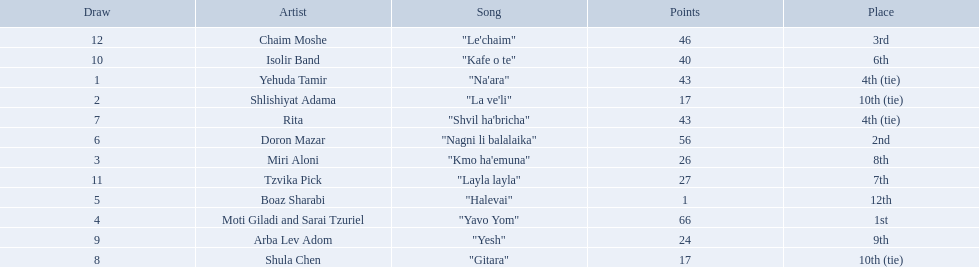How many artists are there? Yehuda Tamir, Shlishiyat Adama, Miri Aloni, Moti Giladi and Sarai Tzuriel, Boaz Sharabi, Doron Mazar, Rita, Shula Chen, Arba Lev Adom, Isolir Band, Tzvika Pick, Chaim Moshe. What is the least amount of points awarded? 1. Who was the artist awarded those points? Boaz Sharabi. 